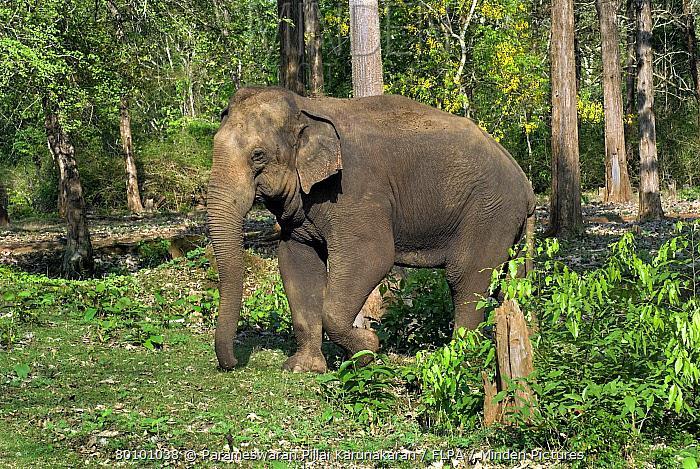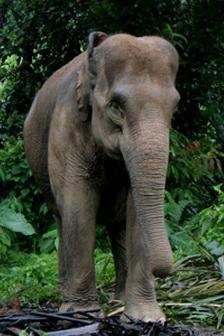The first image is the image on the left, the second image is the image on the right. Given the left and right images, does the statement "There are elephants near a body of water." hold true? Answer yes or no. No. The first image is the image on the left, the second image is the image on the right. For the images displayed, is the sentence "The elephant in the image on the left are standing in a grassy wooded area." factually correct? Answer yes or no. Yes. 